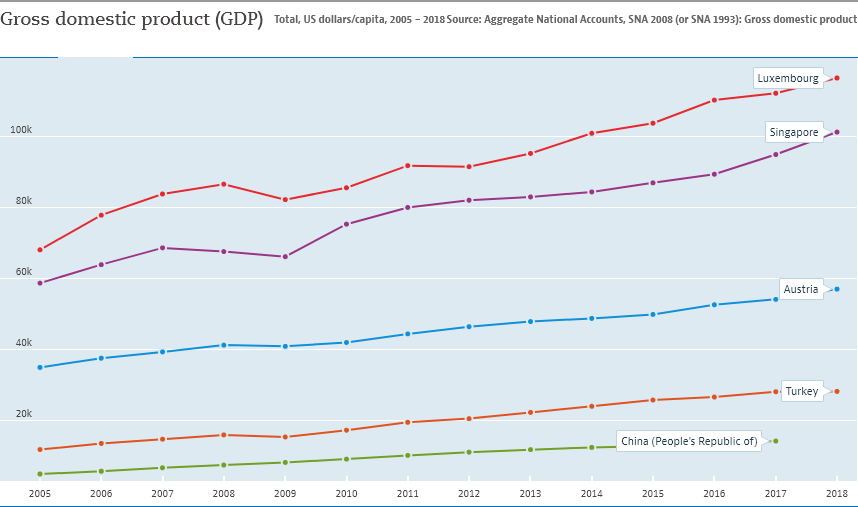Mention a couple of crucial points in this snapshot. The graph shows the value of a certain place, and it is clear that Singapore and Luxembourg have more than 60,000 in value. The color bar located at the top of the graph is red. 